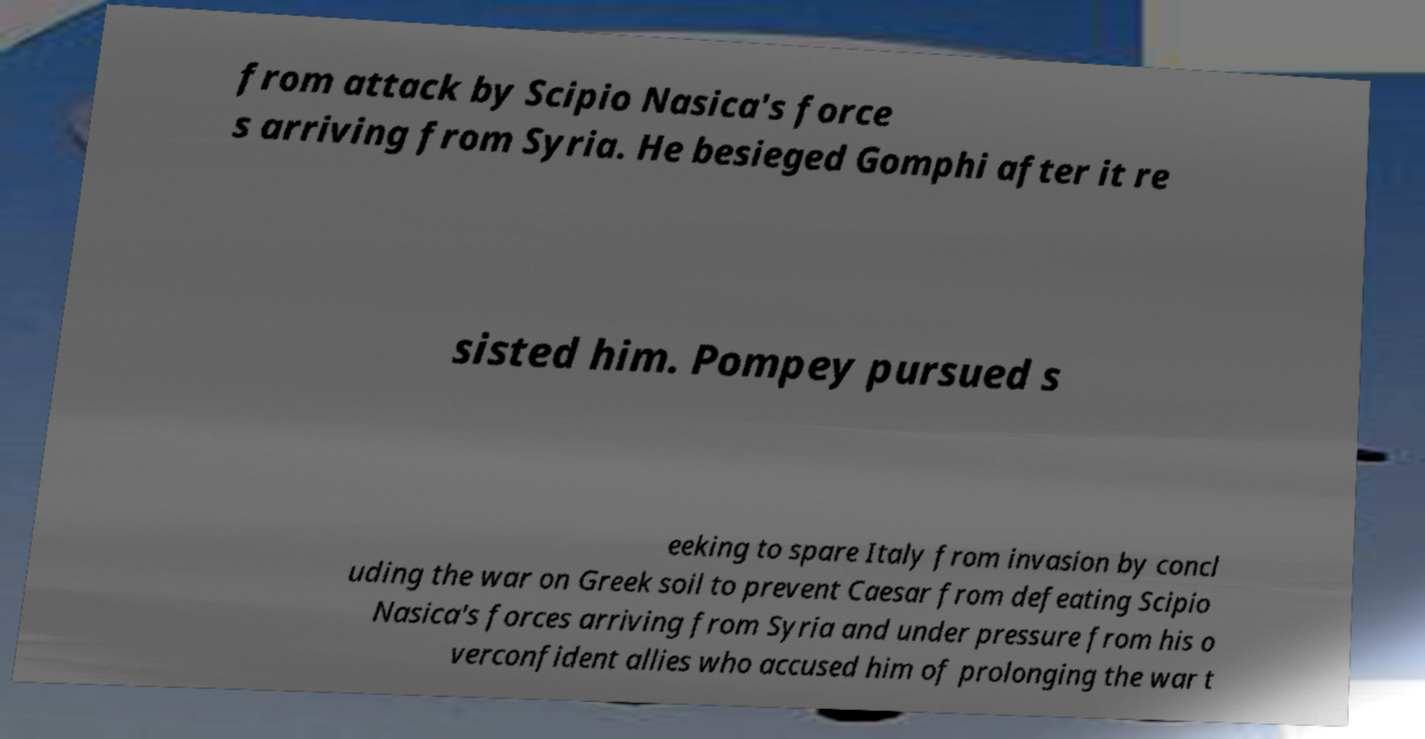What messages or text are displayed in this image? I need them in a readable, typed format. from attack by Scipio Nasica's force s arriving from Syria. He besieged Gomphi after it re sisted him. Pompey pursued s eeking to spare Italy from invasion by concl uding the war on Greek soil to prevent Caesar from defeating Scipio Nasica's forces arriving from Syria and under pressure from his o verconfident allies who accused him of prolonging the war t 